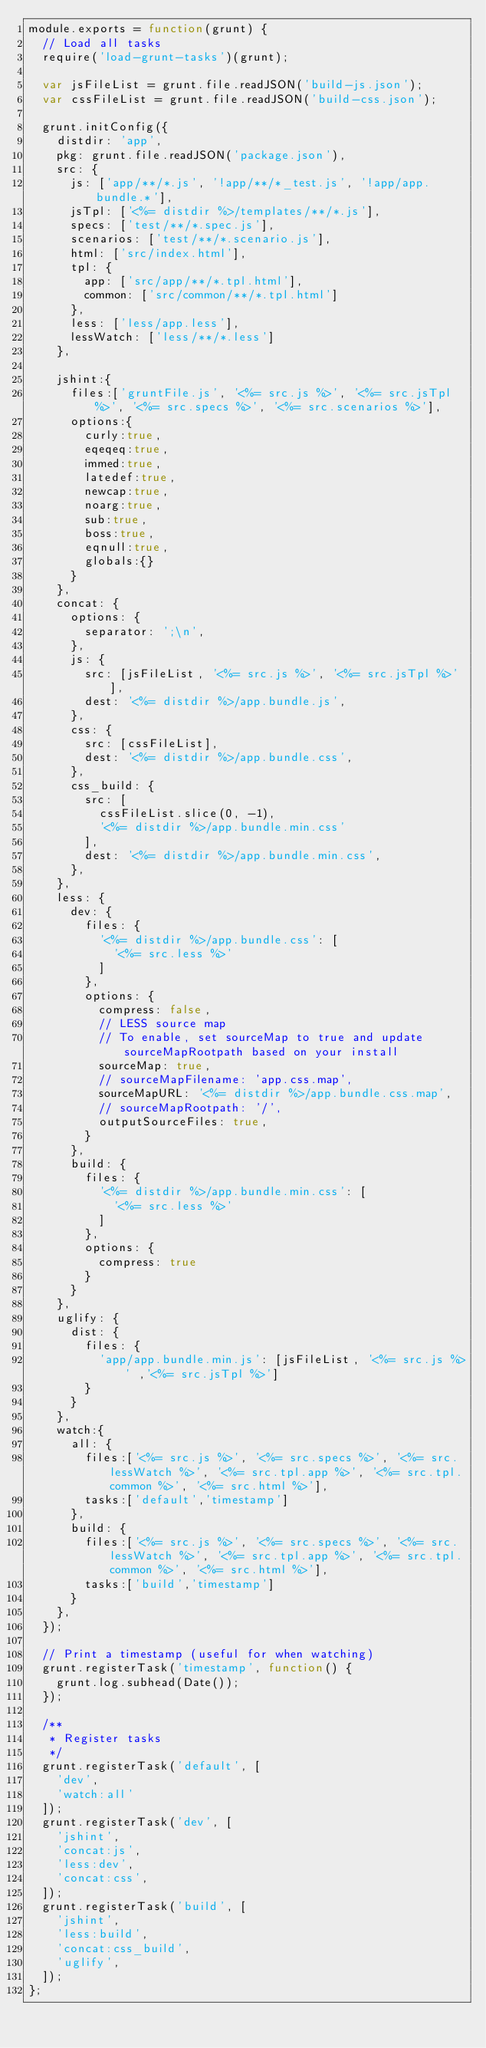Convert code to text. <code><loc_0><loc_0><loc_500><loc_500><_JavaScript_>module.exports = function(grunt) {
  // Load all tasks
  require('load-grunt-tasks')(grunt);

  var jsFileList = grunt.file.readJSON('build-js.json');
  var cssFileList = grunt.file.readJSON('build-css.json');

  grunt.initConfig({
    distdir: 'app',
    pkg: grunt.file.readJSON('package.json'),
    src: {
      js: ['app/**/*.js', '!app/**/*_test.js', '!app/app.bundle.*'],
      jsTpl: ['<%= distdir %>/templates/**/*.js'],
      specs: ['test/**/*.spec.js'],
      scenarios: ['test/**/*.scenario.js'],
      html: ['src/index.html'],
      tpl: {
        app: ['src/app/**/*.tpl.html'],
        common: ['src/common/**/*.tpl.html']
      },
      less: ['less/app.less'],
      lessWatch: ['less/**/*.less']
    },

    jshint:{
      files:['gruntFile.js', '<%= src.js %>', '<%= src.jsTpl %>', '<%= src.specs %>', '<%= src.scenarios %>'],
      options:{
        curly:true,
        eqeqeq:true,
        immed:true,
        latedef:true,
        newcap:true,
        noarg:true,
        sub:true,
        boss:true,
        eqnull:true,
        globals:{}
      }
    },
    concat: {
      options: {
        separator: ';\n',
      },
      js: {
        src: [jsFileList, '<%= src.js %>', '<%= src.jsTpl %>'],
        dest: '<%= distdir %>/app.bundle.js',
      },
      css: {
        src: [cssFileList],
        dest: '<%= distdir %>/app.bundle.css',
      },
      css_build: {
        src: [
          cssFileList.slice(0, -1),
          '<%= distdir %>/app.bundle.min.css'
        ],
        dest: '<%= distdir %>/app.bundle.min.css',
      },
    },
    less: {
      dev: {
        files: {
          '<%= distdir %>/app.bundle.css': [
            '<%= src.less %>'
          ]
        },
        options: {
          compress: false,
          // LESS source map
          // To enable, set sourceMap to true and update sourceMapRootpath based on your install
          sourceMap: true,
          // sourceMapFilename: 'app.css.map',
          sourceMapURL: '<%= distdir %>/app.bundle.css.map',
          // sourceMapRootpath: '/',
          outputSourceFiles: true,
        }
      },
      build: {
        files: {
          '<%= distdir %>/app.bundle.min.css': [
            '<%= src.less %>'
          ]
        },
        options: {
          compress: true
        }
      }
    },
    uglify: {
      dist: {
        files: {
          'app/app.bundle.min.js': [jsFileList, '<%= src.js %>' ,'<%= src.jsTpl %>']
        }
      }
    },
    watch:{
      all: {
        files:['<%= src.js %>', '<%= src.specs %>', '<%= src.lessWatch %>', '<%= src.tpl.app %>', '<%= src.tpl.common %>', '<%= src.html %>'],
        tasks:['default','timestamp']
      },
      build: {
        files:['<%= src.js %>', '<%= src.specs %>', '<%= src.lessWatch %>', '<%= src.tpl.app %>', '<%= src.tpl.common %>', '<%= src.html %>'],
        tasks:['build','timestamp']
      }
    },
  });

  // Print a timestamp (useful for when watching)
  grunt.registerTask('timestamp', function() {
    grunt.log.subhead(Date());
  });

  /**
   * Register tasks
   */
  grunt.registerTask('default', [
    'dev',
    'watch:all'
  ]);
  grunt.registerTask('dev', [
    'jshint',
    'concat:js',
    'less:dev',
    'concat:css',
  ]);
  grunt.registerTask('build', [
    'jshint',
    'less:build',
    'concat:css_build',
    'uglify',
  ]);
};</code> 